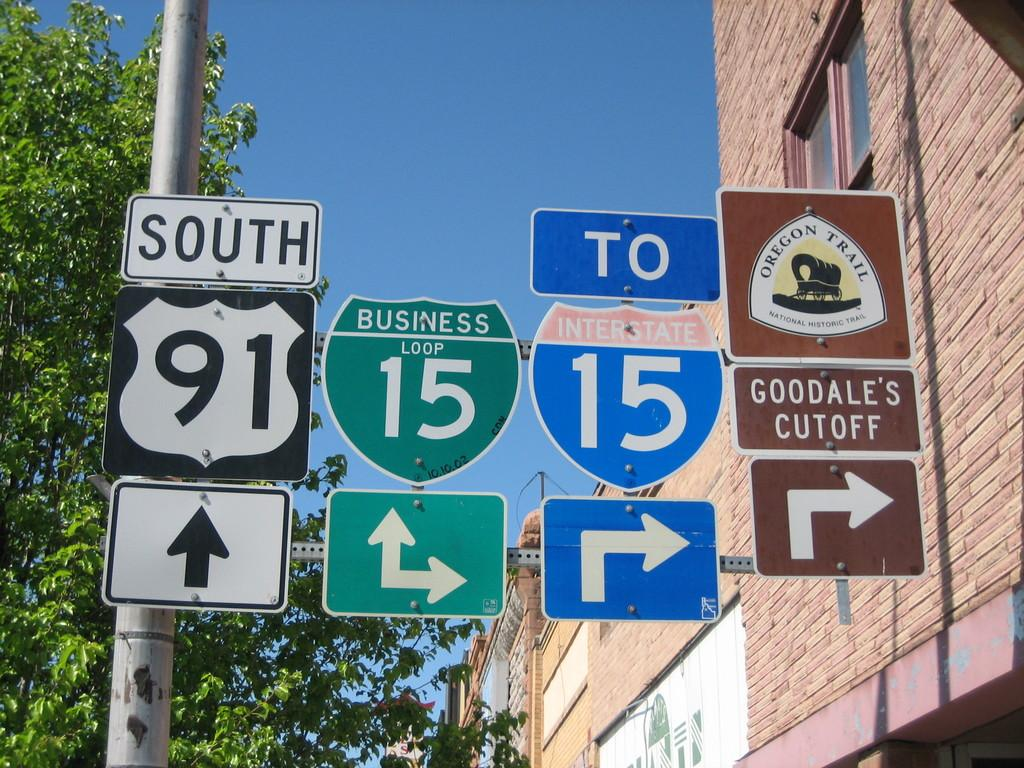<image>
Share a concise interpretation of the image provided. A street sign is labeled 91 south and another designates interstate 15 to the right. 